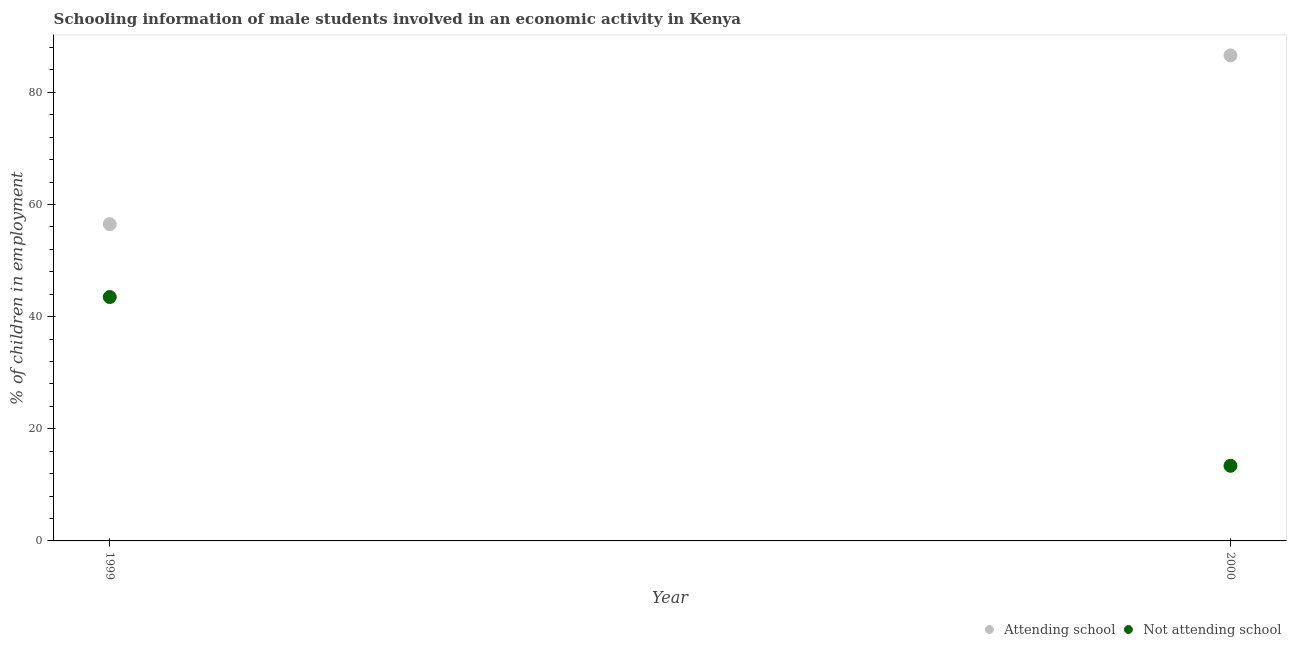How many different coloured dotlines are there?
Your response must be concise. 2. What is the percentage of employed males who are attending school in 1999?
Make the answer very short. 56.5. Across all years, what is the maximum percentage of employed males who are not attending school?
Make the answer very short. 43.5. Across all years, what is the minimum percentage of employed males who are attending school?
Your response must be concise. 56.5. What is the total percentage of employed males who are attending school in the graph?
Give a very brief answer. 143.1. What is the difference between the percentage of employed males who are attending school in 1999 and that in 2000?
Ensure brevity in your answer.  -30.1. What is the difference between the percentage of employed males who are attending school in 1999 and the percentage of employed males who are not attending school in 2000?
Your answer should be compact. 43.1. What is the average percentage of employed males who are attending school per year?
Provide a succinct answer. 71.55. In the year 1999, what is the difference between the percentage of employed males who are attending school and percentage of employed males who are not attending school?
Keep it short and to the point. 13. What is the ratio of the percentage of employed males who are attending school in 1999 to that in 2000?
Give a very brief answer. 0.65. Is the percentage of employed males who are not attending school in 1999 less than that in 2000?
Make the answer very short. No. In how many years, is the percentage of employed males who are attending school greater than the average percentage of employed males who are attending school taken over all years?
Make the answer very short. 1. Does the percentage of employed males who are not attending school monotonically increase over the years?
Ensure brevity in your answer.  No. Is the percentage of employed males who are not attending school strictly less than the percentage of employed males who are attending school over the years?
Give a very brief answer. Yes. How many dotlines are there?
Give a very brief answer. 2. Where does the legend appear in the graph?
Offer a terse response. Bottom right. How are the legend labels stacked?
Provide a short and direct response. Horizontal. What is the title of the graph?
Provide a short and direct response. Schooling information of male students involved in an economic activity in Kenya. Does "Secondary" appear as one of the legend labels in the graph?
Ensure brevity in your answer.  No. What is the label or title of the X-axis?
Provide a short and direct response. Year. What is the label or title of the Y-axis?
Ensure brevity in your answer.  % of children in employment. What is the % of children in employment of Attending school in 1999?
Offer a very short reply. 56.5. What is the % of children in employment in Not attending school in 1999?
Provide a succinct answer. 43.5. What is the % of children in employment of Attending school in 2000?
Your answer should be very brief. 86.6. What is the % of children in employment of Not attending school in 2000?
Provide a succinct answer. 13.4. Across all years, what is the maximum % of children in employment in Attending school?
Provide a short and direct response. 86.6. Across all years, what is the maximum % of children in employment of Not attending school?
Offer a terse response. 43.5. Across all years, what is the minimum % of children in employment in Attending school?
Give a very brief answer. 56.5. Across all years, what is the minimum % of children in employment of Not attending school?
Make the answer very short. 13.4. What is the total % of children in employment of Attending school in the graph?
Your answer should be compact. 143.1. What is the total % of children in employment in Not attending school in the graph?
Keep it short and to the point. 56.9. What is the difference between the % of children in employment of Attending school in 1999 and that in 2000?
Your answer should be very brief. -30.1. What is the difference between the % of children in employment of Not attending school in 1999 and that in 2000?
Give a very brief answer. 30.1. What is the difference between the % of children in employment in Attending school in 1999 and the % of children in employment in Not attending school in 2000?
Provide a short and direct response. 43.1. What is the average % of children in employment in Attending school per year?
Provide a short and direct response. 71.55. What is the average % of children in employment in Not attending school per year?
Provide a succinct answer. 28.45. In the year 1999, what is the difference between the % of children in employment in Attending school and % of children in employment in Not attending school?
Provide a short and direct response. 13. In the year 2000, what is the difference between the % of children in employment in Attending school and % of children in employment in Not attending school?
Offer a terse response. 73.2. What is the ratio of the % of children in employment in Attending school in 1999 to that in 2000?
Your answer should be compact. 0.65. What is the ratio of the % of children in employment in Not attending school in 1999 to that in 2000?
Your answer should be compact. 3.25. What is the difference between the highest and the second highest % of children in employment of Attending school?
Your answer should be very brief. 30.1. What is the difference between the highest and the second highest % of children in employment in Not attending school?
Provide a succinct answer. 30.1. What is the difference between the highest and the lowest % of children in employment of Attending school?
Offer a terse response. 30.1. What is the difference between the highest and the lowest % of children in employment of Not attending school?
Your answer should be compact. 30.1. 